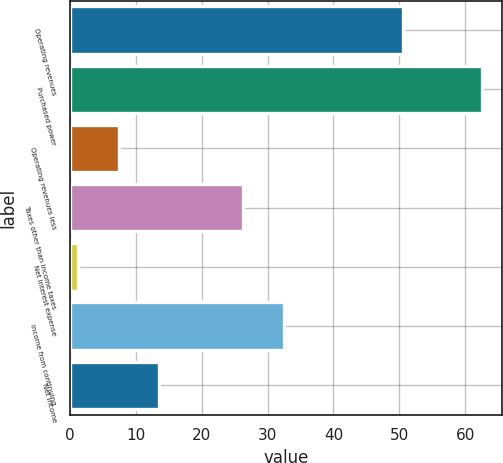Convert chart to OTSL. <chart><loc_0><loc_0><loc_500><loc_500><bar_chart><fcel>Operating revenues<fcel>Purchased power<fcel>Operating revenues less<fcel>Taxes other than income taxes<fcel>Net interest expense<fcel>Income from continuing<fcel>Net income<nl><fcel>50.6<fcel>62.5<fcel>7.42<fcel>26.3<fcel>1.3<fcel>32.42<fcel>13.54<nl></chart> 